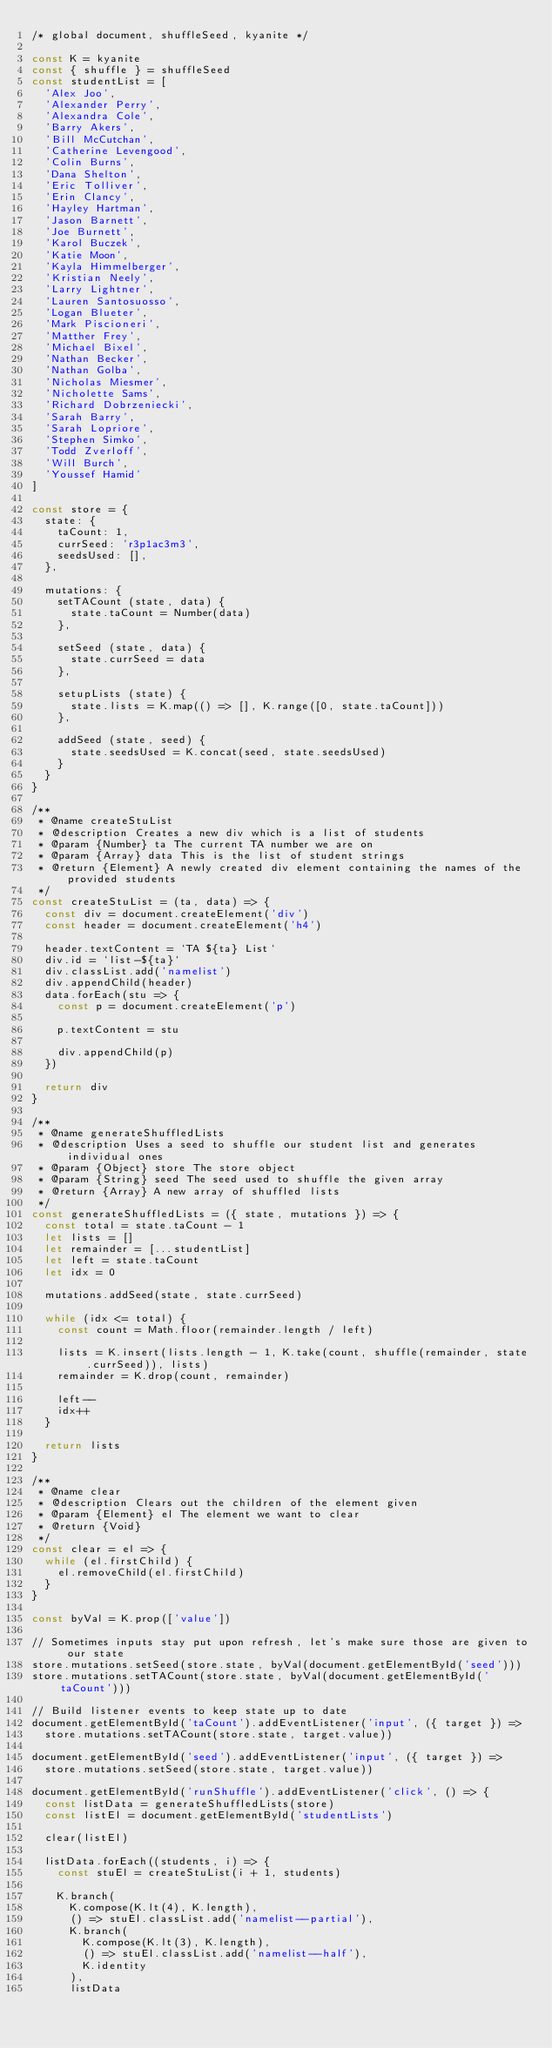<code> <loc_0><loc_0><loc_500><loc_500><_JavaScript_>/* global document, shuffleSeed, kyanite */

const K = kyanite
const { shuffle } = shuffleSeed
const studentList = [
  'Alex Joo',
  'Alexander Perry',
  'Alexandra Cole',
  'Barry Akers',
  'Bill McCutchan',
  'Catherine Levengood',
  'Colin Burns',
  'Dana Shelton',
  'Eric Tolliver',
  'Erin Clancy',
  'Hayley Hartman',
  'Jason Barnett',
  'Joe Burnett',
  'Karol Buczek',
  'Katie Moon',
  'Kayla Himmelberger',
  'Kristian Neely',
  'Larry Lightner',
  'Lauren Santosuosso',
  'Logan Blueter',
  'Mark Piscioneri',
  'Matther Frey',
  'Michael Bixel',
  'Nathan Becker',
  'Nathan Golba',
  'Nicholas Miesmer',
  'Nicholette Sams',
  'Richard Dobrzeniecki',
  'Sarah Barry',
  'Sarah Lopriore',
  'Stephen Simko',
  'Todd Zverloff',
  'Will Burch',
  'Youssef Hamid'
]

const store = {
  state: {
    taCount: 1,
    currSeed: 'r3p1ac3m3',
    seedsUsed: [],
  },

  mutations: {
    setTACount (state, data) {
      state.taCount = Number(data)
    },

    setSeed (state, data) {
      state.currSeed = data
    },

    setupLists (state) {
      state.lists = K.map(() => [], K.range([0, state.taCount]))
    },

    addSeed (state, seed) {
      state.seedsUsed = K.concat(seed, state.seedsUsed)
    }
  }
}

/**
 * @name createStuList
 * @description Creates a new div which is a list of students
 * @param {Number} ta The current TA number we are on
 * @param {Array} data This is the list of student strings
 * @return {Element} A newly created div element containing the names of the provided students
 */
const createStuList = (ta, data) => {
  const div = document.createElement('div')
  const header = document.createElement('h4')

  header.textContent = `TA ${ta} List`
  div.id = `list-${ta}`
  div.classList.add('namelist')
  div.appendChild(header)
  data.forEach(stu => {
    const p = document.createElement('p')

    p.textContent = stu

    div.appendChild(p)
  })

  return div
}

/**
 * @name generateShuffledLists
 * @description Uses a seed to shuffle our student list and generates individual ones
 * @param {Object} store The store object
 * @param {String} seed The seed used to shuffle the given array
 * @return {Array} A new array of shuffled lists
 */
const generateShuffledLists = ({ state, mutations }) => {
  const total = state.taCount - 1
  let lists = []
  let remainder = [...studentList]
  let left = state.taCount
  let idx = 0

  mutations.addSeed(state, state.currSeed)

  while (idx <= total) {
    const count = Math.floor(remainder.length / left)

    lists = K.insert(lists.length - 1, K.take(count, shuffle(remainder, state.currSeed)), lists)
    remainder = K.drop(count, remainder)

    left--
    idx++
  }

  return lists
}

/**
 * @name clear
 * @description Clears out the children of the element given
 * @param {Element} el The element we want to clear
 * @return {Void}
 */
const clear = el => {
  while (el.firstChild) {
    el.removeChild(el.firstChild)
  }
}

const byVal = K.prop(['value'])

// Sometimes inputs stay put upon refresh, let's make sure those are given to our state
store.mutations.setSeed(store.state, byVal(document.getElementById('seed')))
store.mutations.setTACount(store.state, byVal(document.getElementById('taCount')))

// Build listener events to keep state up to date
document.getElementById('taCount').addEventListener('input', ({ target }) =>
  store.mutations.setTACount(store.state, target.value))

document.getElementById('seed').addEventListener('input', ({ target }) =>
  store.mutations.setSeed(store.state, target.value))

document.getElementById('runShuffle').addEventListener('click', () => {
  const listData = generateShuffledLists(store)
  const listEl = document.getElementById('studentLists')

  clear(listEl)

  listData.forEach((students, i) => {
    const stuEl = createStuList(i + 1, students)

    K.branch(
      K.compose(K.lt(4), K.length),
      () => stuEl.classList.add('namelist--partial'),
      K.branch(
        K.compose(K.lt(3), K.length),
        () => stuEl.classList.add('namelist--half'),
        K.identity
      ),
      listData</code> 